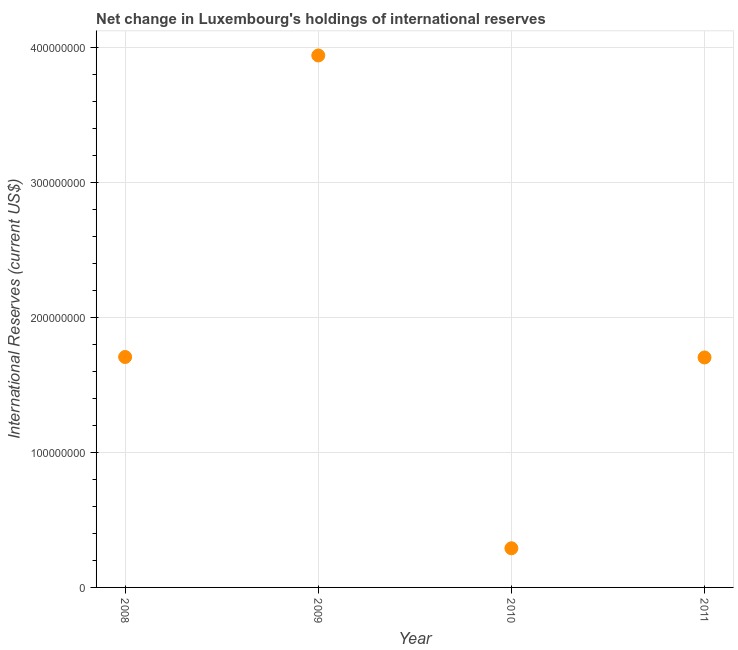What is the reserves and related items in 2008?
Provide a short and direct response. 1.71e+08. Across all years, what is the maximum reserves and related items?
Provide a short and direct response. 3.94e+08. Across all years, what is the minimum reserves and related items?
Give a very brief answer. 2.90e+07. What is the sum of the reserves and related items?
Make the answer very short. 7.64e+08. What is the difference between the reserves and related items in 2008 and 2011?
Give a very brief answer. 3.41e+05. What is the average reserves and related items per year?
Offer a very short reply. 1.91e+08. What is the median reserves and related items?
Offer a terse response. 1.70e+08. Do a majority of the years between 2011 and 2010 (inclusive) have reserves and related items greater than 220000000 US$?
Your answer should be compact. No. What is the ratio of the reserves and related items in 2010 to that in 2011?
Provide a succinct answer. 0.17. Is the difference between the reserves and related items in 2009 and 2011 greater than the difference between any two years?
Your response must be concise. No. What is the difference between the highest and the second highest reserves and related items?
Give a very brief answer. 2.23e+08. Is the sum of the reserves and related items in 2009 and 2010 greater than the maximum reserves and related items across all years?
Give a very brief answer. Yes. What is the difference between the highest and the lowest reserves and related items?
Offer a terse response. 3.65e+08. Does the reserves and related items monotonically increase over the years?
Offer a very short reply. No. What is the difference between two consecutive major ticks on the Y-axis?
Your answer should be very brief. 1.00e+08. Does the graph contain grids?
Provide a short and direct response. Yes. What is the title of the graph?
Your answer should be very brief. Net change in Luxembourg's holdings of international reserves. What is the label or title of the Y-axis?
Ensure brevity in your answer.  International Reserves (current US$). What is the International Reserves (current US$) in 2008?
Make the answer very short. 1.71e+08. What is the International Reserves (current US$) in 2009?
Provide a short and direct response. 3.94e+08. What is the International Reserves (current US$) in 2010?
Make the answer very short. 2.90e+07. What is the International Reserves (current US$) in 2011?
Make the answer very short. 1.70e+08. What is the difference between the International Reserves (current US$) in 2008 and 2009?
Provide a short and direct response. -2.23e+08. What is the difference between the International Reserves (current US$) in 2008 and 2010?
Ensure brevity in your answer.  1.42e+08. What is the difference between the International Reserves (current US$) in 2008 and 2011?
Ensure brevity in your answer.  3.41e+05. What is the difference between the International Reserves (current US$) in 2009 and 2010?
Keep it short and to the point. 3.65e+08. What is the difference between the International Reserves (current US$) in 2009 and 2011?
Ensure brevity in your answer.  2.24e+08. What is the difference between the International Reserves (current US$) in 2010 and 2011?
Keep it short and to the point. -1.41e+08. What is the ratio of the International Reserves (current US$) in 2008 to that in 2009?
Your answer should be compact. 0.43. What is the ratio of the International Reserves (current US$) in 2008 to that in 2010?
Give a very brief answer. 5.88. What is the ratio of the International Reserves (current US$) in 2009 to that in 2010?
Keep it short and to the point. 13.59. What is the ratio of the International Reserves (current US$) in 2009 to that in 2011?
Your answer should be very brief. 2.31. What is the ratio of the International Reserves (current US$) in 2010 to that in 2011?
Provide a short and direct response. 0.17. 